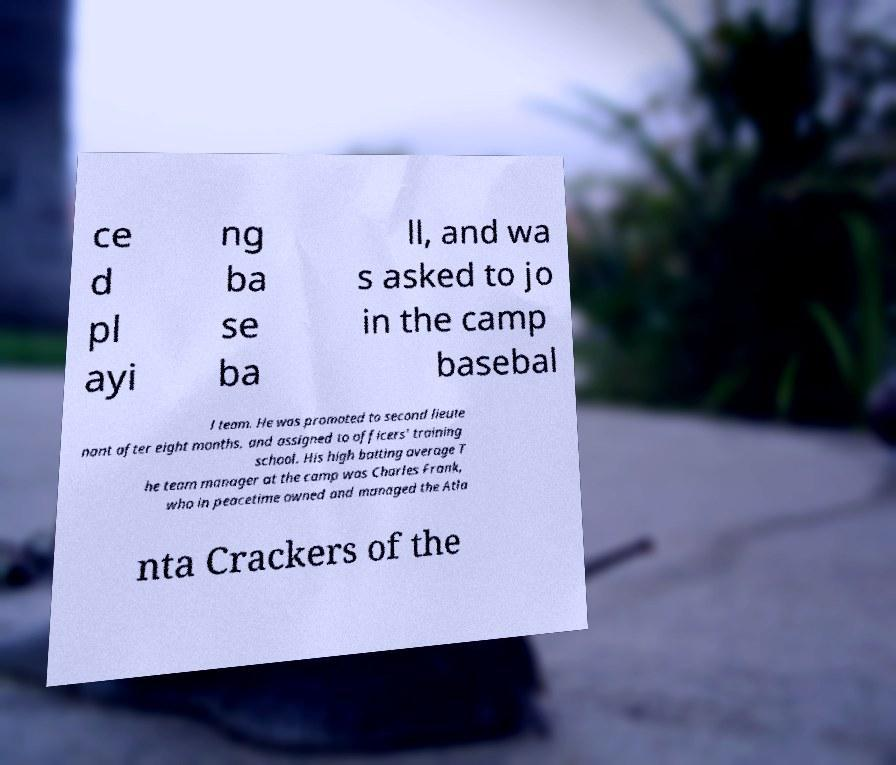I need the written content from this picture converted into text. Can you do that? ce d pl ayi ng ba se ba ll, and wa s asked to jo in the camp basebal l team. He was promoted to second lieute nant after eight months, and assigned to officers' training school. His high batting average T he team manager at the camp was Charles Frank, who in peacetime owned and managed the Atla nta Crackers of the 